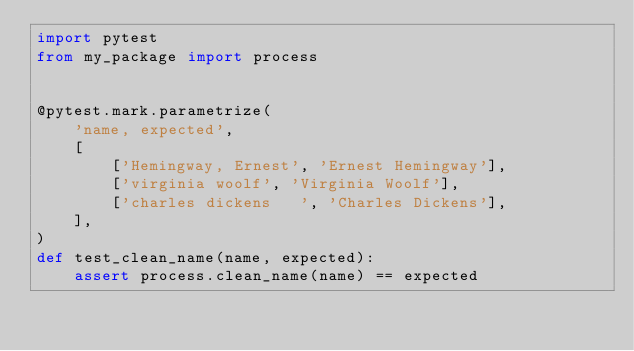Convert code to text. <code><loc_0><loc_0><loc_500><loc_500><_Python_>import pytest
from my_package import process


@pytest.mark.parametrize(
    'name, expected',
    [
        ['Hemingway, Ernest', 'Ernest Hemingway'],
        ['virginia woolf', 'Virginia Woolf'],
        ['charles dickens   ', 'Charles Dickens'],
    ],
)
def test_clean_name(name, expected):
    assert process.clean_name(name) == expected
</code> 